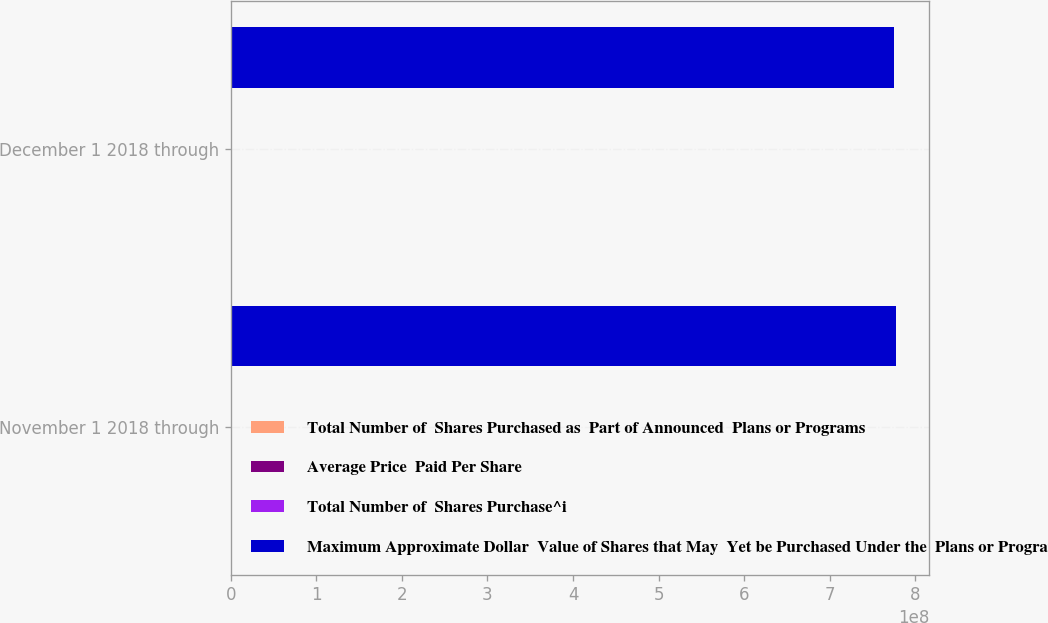<chart> <loc_0><loc_0><loc_500><loc_500><stacked_bar_chart><ecel><fcel>November 1 2018 through<fcel>December 1 2018 through<nl><fcel>Total Number of  Shares Purchased as  Part of Announced  Plans or Programs<fcel>1.29175e+06<fcel>81875<nl><fcel>Average Price  Paid Per Share<fcel>35.46<fcel>34.95<nl><fcel>Total Number of  Shares Purchase^i<fcel>1.29175e+06<fcel>71530<nl><fcel>Maximum Approximate Dollar  Value of Shares that May  Yet be Purchased Under the  Plans or Programs<fcel>7.77398e+08<fcel>7.74898e+08<nl></chart> 